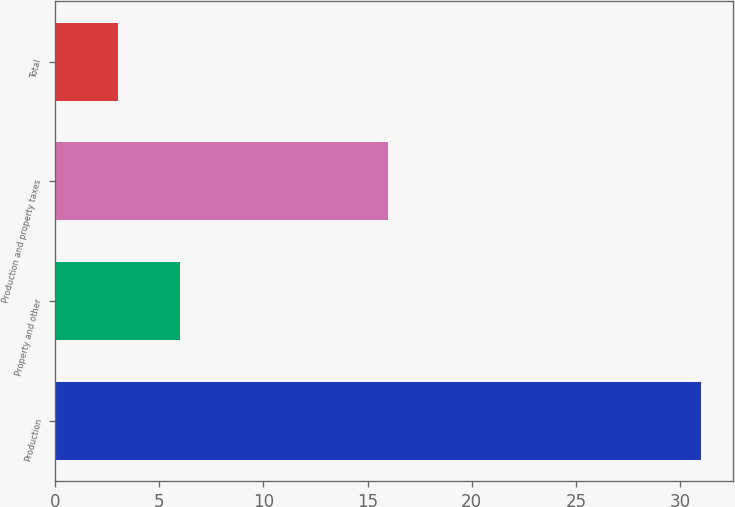Convert chart to OTSL. <chart><loc_0><loc_0><loc_500><loc_500><bar_chart><fcel>Production<fcel>Property and other<fcel>Production and property taxes<fcel>Total<nl><fcel>31<fcel>6<fcel>16<fcel>3.02<nl></chart> 